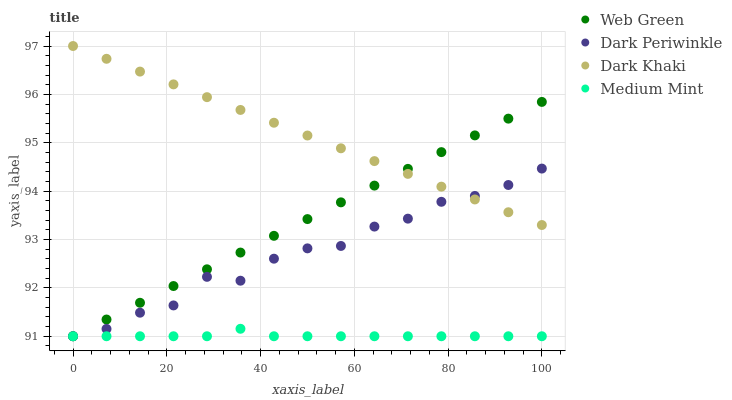Does Medium Mint have the minimum area under the curve?
Answer yes or no. Yes. Does Dark Khaki have the maximum area under the curve?
Answer yes or no. Yes. Does Dark Periwinkle have the minimum area under the curve?
Answer yes or no. No. Does Dark Periwinkle have the maximum area under the curve?
Answer yes or no. No. Is Web Green the smoothest?
Answer yes or no. Yes. Is Dark Periwinkle the roughest?
Answer yes or no. Yes. Is Medium Mint the smoothest?
Answer yes or no. No. Is Medium Mint the roughest?
Answer yes or no. No. Does Medium Mint have the lowest value?
Answer yes or no. Yes. Does Dark Khaki have the highest value?
Answer yes or no. Yes. Does Dark Periwinkle have the highest value?
Answer yes or no. No. Is Medium Mint less than Dark Khaki?
Answer yes or no. Yes. Is Dark Khaki greater than Medium Mint?
Answer yes or no. Yes. Does Medium Mint intersect Dark Periwinkle?
Answer yes or no. Yes. Is Medium Mint less than Dark Periwinkle?
Answer yes or no. No. Is Medium Mint greater than Dark Periwinkle?
Answer yes or no. No. Does Medium Mint intersect Dark Khaki?
Answer yes or no. No. 